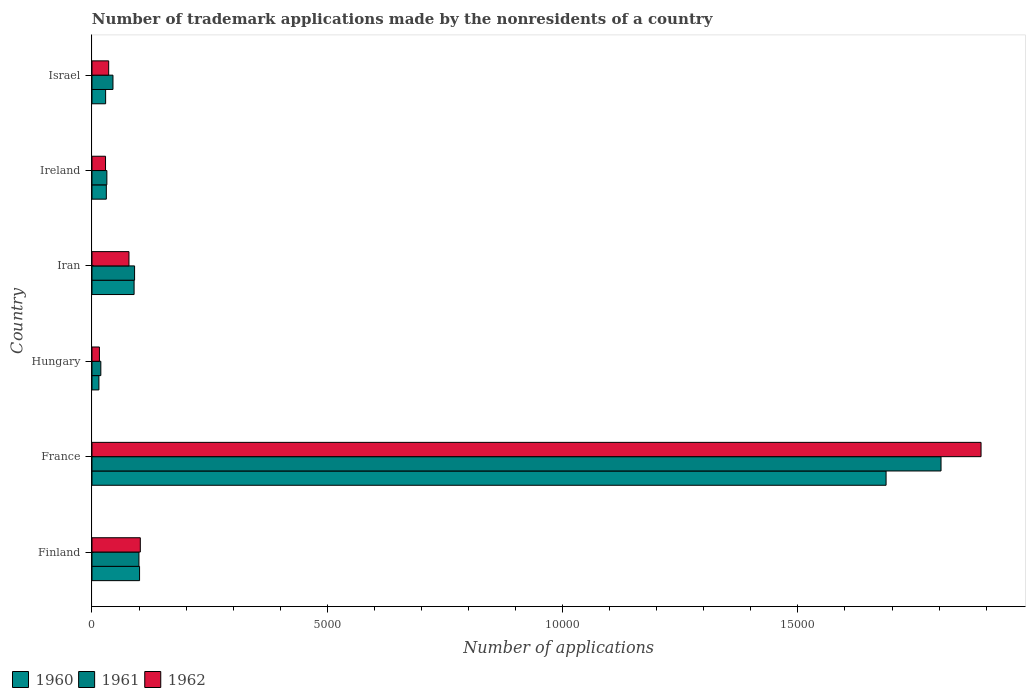How many different coloured bars are there?
Give a very brief answer. 3. Are the number of bars per tick equal to the number of legend labels?
Make the answer very short. Yes. Are the number of bars on each tick of the Y-axis equal?
Your response must be concise. Yes. How many bars are there on the 5th tick from the top?
Your answer should be compact. 3. What is the label of the 3rd group of bars from the top?
Your answer should be very brief. Iran. What is the number of trademark applications made by the nonresidents in 1961 in Hungary?
Offer a terse response. 188. Across all countries, what is the maximum number of trademark applications made by the nonresidents in 1961?
Keep it short and to the point. 1.80e+04. Across all countries, what is the minimum number of trademark applications made by the nonresidents in 1960?
Your answer should be compact. 147. In which country was the number of trademark applications made by the nonresidents in 1961 maximum?
Give a very brief answer. France. In which country was the number of trademark applications made by the nonresidents in 1961 minimum?
Your response must be concise. Hungary. What is the total number of trademark applications made by the nonresidents in 1961 in the graph?
Keep it short and to the point. 2.09e+04. What is the difference between the number of trademark applications made by the nonresidents in 1961 in France and that in Ireland?
Provide a succinct answer. 1.77e+04. What is the difference between the number of trademark applications made by the nonresidents in 1960 in Israel and the number of trademark applications made by the nonresidents in 1961 in Hungary?
Offer a very short reply. 102. What is the average number of trademark applications made by the nonresidents in 1962 per country?
Provide a short and direct response. 3584.33. What is the difference between the number of trademark applications made by the nonresidents in 1961 and number of trademark applications made by the nonresidents in 1960 in Israel?
Provide a succinct answer. 156. In how many countries, is the number of trademark applications made by the nonresidents in 1962 greater than 10000 ?
Your answer should be very brief. 1. What is the ratio of the number of trademark applications made by the nonresidents in 1960 in France to that in Israel?
Your answer should be compact. 58.19. What is the difference between the highest and the second highest number of trademark applications made by the nonresidents in 1960?
Make the answer very short. 1.59e+04. What is the difference between the highest and the lowest number of trademark applications made by the nonresidents in 1960?
Provide a succinct answer. 1.67e+04. What does the 3rd bar from the top in Ireland represents?
Your response must be concise. 1960. What does the 3rd bar from the bottom in Israel represents?
Offer a very short reply. 1962. Is it the case that in every country, the sum of the number of trademark applications made by the nonresidents in 1961 and number of trademark applications made by the nonresidents in 1960 is greater than the number of trademark applications made by the nonresidents in 1962?
Provide a succinct answer. Yes. How many bars are there?
Your answer should be compact. 18. Are all the bars in the graph horizontal?
Give a very brief answer. Yes. How many countries are there in the graph?
Keep it short and to the point. 6. What is the difference between two consecutive major ticks on the X-axis?
Ensure brevity in your answer.  5000. Where does the legend appear in the graph?
Your answer should be compact. Bottom left. How many legend labels are there?
Your response must be concise. 3. How are the legend labels stacked?
Make the answer very short. Horizontal. What is the title of the graph?
Offer a terse response. Number of trademark applications made by the nonresidents of a country. Does "1986" appear as one of the legend labels in the graph?
Offer a terse response. No. What is the label or title of the X-axis?
Offer a terse response. Number of applications. What is the label or title of the Y-axis?
Your answer should be very brief. Country. What is the Number of applications in 1960 in Finland?
Keep it short and to the point. 1011. What is the Number of applications in 1961 in Finland?
Provide a short and direct response. 998. What is the Number of applications of 1962 in Finland?
Provide a succinct answer. 1027. What is the Number of applications in 1960 in France?
Ensure brevity in your answer.  1.69e+04. What is the Number of applications in 1961 in France?
Keep it short and to the point. 1.80e+04. What is the Number of applications in 1962 in France?
Your response must be concise. 1.89e+04. What is the Number of applications of 1960 in Hungary?
Offer a very short reply. 147. What is the Number of applications of 1961 in Hungary?
Give a very brief answer. 188. What is the Number of applications in 1962 in Hungary?
Give a very brief answer. 158. What is the Number of applications in 1960 in Iran?
Your answer should be compact. 895. What is the Number of applications in 1961 in Iran?
Provide a short and direct response. 905. What is the Number of applications in 1962 in Iran?
Keep it short and to the point. 786. What is the Number of applications of 1960 in Ireland?
Your answer should be very brief. 305. What is the Number of applications of 1961 in Ireland?
Provide a short and direct response. 316. What is the Number of applications in 1962 in Ireland?
Provide a succinct answer. 288. What is the Number of applications of 1960 in Israel?
Give a very brief answer. 290. What is the Number of applications in 1961 in Israel?
Provide a succinct answer. 446. What is the Number of applications of 1962 in Israel?
Ensure brevity in your answer.  355. Across all countries, what is the maximum Number of applications of 1960?
Make the answer very short. 1.69e+04. Across all countries, what is the maximum Number of applications in 1961?
Make the answer very short. 1.80e+04. Across all countries, what is the maximum Number of applications in 1962?
Keep it short and to the point. 1.89e+04. Across all countries, what is the minimum Number of applications in 1960?
Keep it short and to the point. 147. Across all countries, what is the minimum Number of applications of 1961?
Provide a succinct answer. 188. Across all countries, what is the minimum Number of applications in 1962?
Keep it short and to the point. 158. What is the total Number of applications in 1960 in the graph?
Keep it short and to the point. 1.95e+04. What is the total Number of applications of 1961 in the graph?
Provide a short and direct response. 2.09e+04. What is the total Number of applications of 1962 in the graph?
Your answer should be very brief. 2.15e+04. What is the difference between the Number of applications in 1960 in Finland and that in France?
Offer a very short reply. -1.59e+04. What is the difference between the Number of applications in 1961 in Finland and that in France?
Provide a succinct answer. -1.70e+04. What is the difference between the Number of applications in 1962 in Finland and that in France?
Give a very brief answer. -1.79e+04. What is the difference between the Number of applications of 1960 in Finland and that in Hungary?
Make the answer very short. 864. What is the difference between the Number of applications of 1961 in Finland and that in Hungary?
Your response must be concise. 810. What is the difference between the Number of applications in 1962 in Finland and that in Hungary?
Your answer should be very brief. 869. What is the difference between the Number of applications of 1960 in Finland and that in Iran?
Ensure brevity in your answer.  116. What is the difference between the Number of applications in 1961 in Finland and that in Iran?
Offer a terse response. 93. What is the difference between the Number of applications of 1962 in Finland and that in Iran?
Offer a terse response. 241. What is the difference between the Number of applications in 1960 in Finland and that in Ireland?
Make the answer very short. 706. What is the difference between the Number of applications in 1961 in Finland and that in Ireland?
Provide a short and direct response. 682. What is the difference between the Number of applications of 1962 in Finland and that in Ireland?
Provide a short and direct response. 739. What is the difference between the Number of applications in 1960 in Finland and that in Israel?
Give a very brief answer. 721. What is the difference between the Number of applications in 1961 in Finland and that in Israel?
Offer a very short reply. 552. What is the difference between the Number of applications of 1962 in Finland and that in Israel?
Offer a very short reply. 672. What is the difference between the Number of applications of 1960 in France and that in Hungary?
Your response must be concise. 1.67e+04. What is the difference between the Number of applications in 1961 in France and that in Hungary?
Provide a succinct answer. 1.79e+04. What is the difference between the Number of applications of 1962 in France and that in Hungary?
Offer a very short reply. 1.87e+04. What is the difference between the Number of applications in 1960 in France and that in Iran?
Ensure brevity in your answer.  1.60e+04. What is the difference between the Number of applications in 1961 in France and that in Iran?
Give a very brief answer. 1.71e+04. What is the difference between the Number of applications in 1962 in France and that in Iran?
Provide a short and direct response. 1.81e+04. What is the difference between the Number of applications of 1960 in France and that in Ireland?
Your response must be concise. 1.66e+04. What is the difference between the Number of applications of 1961 in France and that in Ireland?
Provide a short and direct response. 1.77e+04. What is the difference between the Number of applications of 1962 in France and that in Ireland?
Provide a short and direct response. 1.86e+04. What is the difference between the Number of applications of 1960 in France and that in Israel?
Ensure brevity in your answer.  1.66e+04. What is the difference between the Number of applications in 1961 in France and that in Israel?
Your answer should be compact. 1.76e+04. What is the difference between the Number of applications in 1962 in France and that in Israel?
Keep it short and to the point. 1.85e+04. What is the difference between the Number of applications of 1960 in Hungary and that in Iran?
Offer a terse response. -748. What is the difference between the Number of applications in 1961 in Hungary and that in Iran?
Offer a very short reply. -717. What is the difference between the Number of applications of 1962 in Hungary and that in Iran?
Keep it short and to the point. -628. What is the difference between the Number of applications of 1960 in Hungary and that in Ireland?
Your answer should be very brief. -158. What is the difference between the Number of applications of 1961 in Hungary and that in Ireland?
Provide a succinct answer. -128. What is the difference between the Number of applications of 1962 in Hungary and that in Ireland?
Provide a short and direct response. -130. What is the difference between the Number of applications in 1960 in Hungary and that in Israel?
Give a very brief answer. -143. What is the difference between the Number of applications of 1961 in Hungary and that in Israel?
Provide a short and direct response. -258. What is the difference between the Number of applications in 1962 in Hungary and that in Israel?
Offer a very short reply. -197. What is the difference between the Number of applications of 1960 in Iran and that in Ireland?
Give a very brief answer. 590. What is the difference between the Number of applications of 1961 in Iran and that in Ireland?
Keep it short and to the point. 589. What is the difference between the Number of applications in 1962 in Iran and that in Ireland?
Provide a short and direct response. 498. What is the difference between the Number of applications of 1960 in Iran and that in Israel?
Keep it short and to the point. 605. What is the difference between the Number of applications of 1961 in Iran and that in Israel?
Ensure brevity in your answer.  459. What is the difference between the Number of applications in 1962 in Iran and that in Israel?
Keep it short and to the point. 431. What is the difference between the Number of applications in 1961 in Ireland and that in Israel?
Keep it short and to the point. -130. What is the difference between the Number of applications of 1962 in Ireland and that in Israel?
Give a very brief answer. -67. What is the difference between the Number of applications of 1960 in Finland and the Number of applications of 1961 in France?
Offer a very short reply. -1.70e+04. What is the difference between the Number of applications of 1960 in Finland and the Number of applications of 1962 in France?
Provide a short and direct response. -1.79e+04. What is the difference between the Number of applications of 1961 in Finland and the Number of applications of 1962 in France?
Give a very brief answer. -1.79e+04. What is the difference between the Number of applications in 1960 in Finland and the Number of applications in 1961 in Hungary?
Provide a succinct answer. 823. What is the difference between the Number of applications of 1960 in Finland and the Number of applications of 1962 in Hungary?
Make the answer very short. 853. What is the difference between the Number of applications of 1961 in Finland and the Number of applications of 1962 in Hungary?
Keep it short and to the point. 840. What is the difference between the Number of applications of 1960 in Finland and the Number of applications of 1961 in Iran?
Offer a terse response. 106. What is the difference between the Number of applications in 1960 in Finland and the Number of applications in 1962 in Iran?
Offer a very short reply. 225. What is the difference between the Number of applications in 1961 in Finland and the Number of applications in 1962 in Iran?
Give a very brief answer. 212. What is the difference between the Number of applications in 1960 in Finland and the Number of applications in 1961 in Ireland?
Your response must be concise. 695. What is the difference between the Number of applications in 1960 in Finland and the Number of applications in 1962 in Ireland?
Offer a terse response. 723. What is the difference between the Number of applications of 1961 in Finland and the Number of applications of 1962 in Ireland?
Offer a terse response. 710. What is the difference between the Number of applications in 1960 in Finland and the Number of applications in 1961 in Israel?
Your response must be concise. 565. What is the difference between the Number of applications of 1960 in Finland and the Number of applications of 1962 in Israel?
Make the answer very short. 656. What is the difference between the Number of applications of 1961 in Finland and the Number of applications of 1962 in Israel?
Make the answer very short. 643. What is the difference between the Number of applications in 1960 in France and the Number of applications in 1961 in Hungary?
Your response must be concise. 1.67e+04. What is the difference between the Number of applications of 1960 in France and the Number of applications of 1962 in Hungary?
Ensure brevity in your answer.  1.67e+04. What is the difference between the Number of applications in 1961 in France and the Number of applications in 1962 in Hungary?
Provide a short and direct response. 1.79e+04. What is the difference between the Number of applications of 1960 in France and the Number of applications of 1961 in Iran?
Your answer should be compact. 1.60e+04. What is the difference between the Number of applications in 1960 in France and the Number of applications in 1962 in Iran?
Ensure brevity in your answer.  1.61e+04. What is the difference between the Number of applications of 1961 in France and the Number of applications of 1962 in Iran?
Your answer should be compact. 1.73e+04. What is the difference between the Number of applications of 1960 in France and the Number of applications of 1961 in Ireland?
Keep it short and to the point. 1.66e+04. What is the difference between the Number of applications in 1960 in France and the Number of applications in 1962 in Ireland?
Offer a very short reply. 1.66e+04. What is the difference between the Number of applications of 1961 in France and the Number of applications of 1962 in Ireland?
Offer a very short reply. 1.78e+04. What is the difference between the Number of applications in 1960 in France and the Number of applications in 1961 in Israel?
Make the answer very short. 1.64e+04. What is the difference between the Number of applications in 1960 in France and the Number of applications in 1962 in Israel?
Give a very brief answer. 1.65e+04. What is the difference between the Number of applications of 1961 in France and the Number of applications of 1962 in Israel?
Your answer should be compact. 1.77e+04. What is the difference between the Number of applications of 1960 in Hungary and the Number of applications of 1961 in Iran?
Offer a very short reply. -758. What is the difference between the Number of applications of 1960 in Hungary and the Number of applications of 1962 in Iran?
Offer a very short reply. -639. What is the difference between the Number of applications of 1961 in Hungary and the Number of applications of 1962 in Iran?
Provide a short and direct response. -598. What is the difference between the Number of applications of 1960 in Hungary and the Number of applications of 1961 in Ireland?
Your answer should be compact. -169. What is the difference between the Number of applications of 1960 in Hungary and the Number of applications of 1962 in Ireland?
Offer a very short reply. -141. What is the difference between the Number of applications in 1961 in Hungary and the Number of applications in 1962 in Ireland?
Give a very brief answer. -100. What is the difference between the Number of applications in 1960 in Hungary and the Number of applications in 1961 in Israel?
Offer a very short reply. -299. What is the difference between the Number of applications in 1960 in Hungary and the Number of applications in 1962 in Israel?
Your answer should be very brief. -208. What is the difference between the Number of applications of 1961 in Hungary and the Number of applications of 1962 in Israel?
Provide a succinct answer. -167. What is the difference between the Number of applications of 1960 in Iran and the Number of applications of 1961 in Ireland?
Give a very brief answer. 579. What is the difference between the Number of applications in 1960 in Iran and the Number of applications in 1962 in Ireland?
Offer a very short reply. 607. What is the difference between the Number of applications of 1961 in Iran and the Number of applications of 1962 in Ireland?
Ensure brevity in your answer.  617. What is the difference between the Number of applications of 1960 in Iran and the Number of applications of 1961 in Israel?
Your answer should be compact. 449. What is the difference between the Number of applications of 1960 in Iran and the Number of applications of 1962 in Israel?
Make the answer very short. 540. What is the difference between the Number of applications in 1961 in Iran and the Number of applications in 1962 in Israel?
Your response must be concise. 550. What is the difference between the Number of applications of 1960 in Ireland and the Number of applications of 1961 in Israel?
Offer a very short reply. -141. What is the difference between the Number of applications of 1961 in Ireland and the Number of applications of 1962 in Israel?
Provide a succinct answer. -39. What is the average Number of applications in 1960 per country?
Your answer should be compact. 3253.67. What is the average Number of applications in 1961 per country?
Offer a very short reply. 3482.5. What is the average Number of applications in 1962 per country?
Give a very brief answer. 3584.33. What is the difference between the Number of applications of 1960 and Number of applications of 1962 in Finland?
Give a very brief answer. -16. What is the difference between the Number of applications in 1960 and Number of applications in 1961 in France?
Your response must be concise. -1168. What is the difference between the Number of applications in 1960 and Number of applications in 1962 in France?
Provide a succinct answer. -2018. What is the difference between the Number of applications of 1961 and Number of applications of 1962 in France?
Your answer should be very brief. -850. What is the difference between the Number of applications in 1960 and Number of applications in 1961 in Hungary?
Offer a very short reply. -41. What is the difference between the Number of applications of 1961 and Number of applications of 1962 in Hungary?
Your response must be concise. 30. What is the difference between the Number of applications in 1960 and Number of applications in 1962 in Iran?
Give a very brief answer. 109. What is the difference between the Number of applications of 1961 and Number of applications of 1962 in Iran?
Make the answer very short. 119. What is the difference between the Number of applications in 1961 and Number of applications in 1962 in Ireland?
Give a very brief answer. 28. What is the difference between the Number of applications of 1960 and Number of applications of 1961 in Israel?
Provide a succinct answer. -156. What is the difference between the Number of applications of 1960 and Number of applications of 1962 in Israel?
Offer a very short reply. -65. What is the difference between the Number of applications of 1961 and Number of applications of 1962 in Israel?
Make the answer very short. 91. What is the ratio of the Number of applications in 1960 in Finland to that in France?
Keep it short and to the point. 0.06. What is the ratio of the Number of applications in 1961 in Finland to that in France?
Give a very brief answer. 0.06. What is the ratio of the Number of applications in 1962 in Finland to that in France?
Ensure brevity in your answer.  0.05. What is the ratio of the Number of applications in 1960 in Finland to that in Hungary?
Keep it short and to the point. 6.88. What is the ratio of the Number of applications of 1961 in Finland to that in Hungary?
Your answer should be compact. 5.31. What is the ratio of the Number of applications of 1962 in Finland to that in Hungary?
Provide a succinct answer. 6.5. What is the ratio of the Number of applications in 1960 in Finland to that in Iran?
Offer a very short reply. 1.13. What is the ratio of the Number of applications in 1961 in Finland to that in Iran?
Your answer should be very brief. 1.1. What is the ratio of the Number of applications of 1962 in Finland to that in Iran?
Your response must be concise. 1.31. What is the ratio of the Number of applications in 1960 in Finland to that in Ireland?
Provide a short and direct response. 3.31. What is the ratio of the Number of applications in 1961 in Finland to that in Ireland?
Ensure brevity in your answer.  3.16. What is the ratio of the Number of applications of 1962 in Finland to that in Ireland?
Make the answer very short. 3.57. What is the ratio of the Number of applications in 1960 in Finland to that in Israel?
Your answer should be compact. 3.49. What is the ratio of the Number of applications of 1961 in Finland to that in Israel?
Ensure brevity in your answer.  2.24. What is the ratio of the Number of applications of 1962 in Finland to that in Israel?
Your answer should be very brief. 2.89. What is the ratio of the Number of applications in 1960 in France to that in Hungary?
Provide a short and direct response. 114.79. What is the ratio of the Number of applications in 1961 in France to that in Hungary?
Your answer should be compact. 95.97. What is the ratio of the Number of applications of 1962 in France to that in Hungary?
Give a very brief answer. 119.57. What is the ratio of the Number of applications in 1960 in France to that in Iran?
Your answer should be very brief. 18.85. What is the ratio of the Number of applications of 1961 in France to that in Iran?
Provide a succinct answer. 19.94. What is the ratio of the Number of applications in 1962 in France to that in Iran?
Your response must be concise. 24.04. What is the ratio of the Number of applications of 1960 in France to that in Ireland?
Provide a succinct answer. 55.32. What is the ratio of the Number of applications in 1961 in France to that in Ireland?
Offer a terse response. 57.09. What is the ratio of the Number of applications in 1962 in France to that in Ireland?
Your answer should be very brief. 65.6. What is the ratio of the Number of applications of 1960 in France to that in Israel?
Ensure brevity in your answer.  58.19. What is the ratio of the Number of applications of 1961 in France to that in Israel?
Give a very brief answer. 40.45. What is the ratio of the Number of applications in 1962 in France to that in Israel?
Keep it short and to the point. 53.22. What is the ratio of the Number of applications in 1960 in Hungary to that in Iran?
Give a very brief answer. 0.16. What is the ratio of the Number of applications in 1961 in Hungary to that in Iran?
Make the answer very short. 0.21. What is the ratio of the Number of applications of 1962 in Hungary to that in Iran?
Make the answer very short. 0.2. What is the ratio of the Number of applications of 1960 in Hungary to that in Ireland?
Make the answer very short. 0.48. What is the ratio of the Number of applications in 1961 in Hungary to that in Ireland?
Your answer should be very brief. 0.59. What is the ratio of the Number of applications in 1962 in Hungary to that in Ireland?
Offer a terse response. 0.55. What is the ratio of the Number of applications of 1960 in Hungary to that in Israel?
Offer a terse response. 0.51. What is the ratio of the Number of applications of 1961 in Hungary to that in Israel?
Provide a succinct answer. 0.42. What is the ratio of the Number of applications in 1962 in Hungary to that in Israel?
Offer a very short reply. 0.45. What is the ratio of the Number of applications of 1960 in Iran to that in Ireland?
Your answer should be compact. 2.93. What is the ratio of the Number of applications of 1961 in Iran to that in Ireland?
Provide a succinct answer. 2.86. What is the ratio of the Number of applications in 1962 in Iran to that in Ireland?
Make the answer very short. 2.73. What is the ratio of the Number of applications in 1960 in Iran to that in Israel?
Your response must be concise. 3.09. What is the ratio of the Number of applications of 1961 in Iran to that in Israel?
Offer a very short reply. 2.03. What is the ratio of the Number of applications in 1962 in Iran to that in Israel?
Your answer should be very brief. 2.21. What is the ratio of the Number of applications in 1960 in Ireland to that in Israel?
Keep it short and to the point. 1.05. What is the ratio of the Number of applications of 1961 in Ireland to that in Israel?
Ensure brevity in your answer.  0.71. What is the ratio of the Number of applications in 1962 in Ireland to that in Israel?
Offer a very short reply. 0.81. What is the difference between the highest and the second highest Number of applications of 1960?
Make the answer very short. 1.59e+04. What is the difference between the highest and the second highest Number of applications in 1961?
Your answer should be very brief. 1.70e+04. What is the difference between the highest and the second highest Number of applications in 1962?
Keep it short and to the point. 1.79e+04. What is the difference between the highest and the lowest Number of applications in 1960?
Give a very brief answer. 1.67e+04. What is the difference between the highest and the lowest Number of applications of 1961?
Ensure brevity in your answer.  1.79e+04. What is the difference between the highest and the lowest Number of applications of 1962?
Provide a short and direct response. 1.87e+04. 